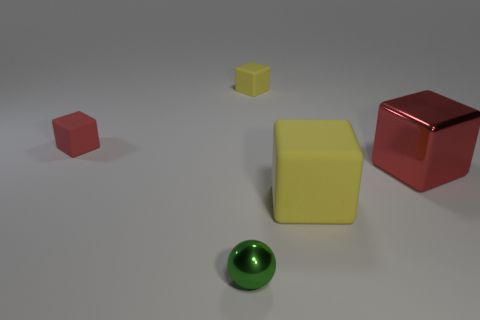There is a yellow thing that is in front of the red cube right of the small red matte object; what size is it?
Provide a succinct answer. Large. Is there another small metal thing that has the same shape as the green metallic object?
Make the answer very short. No. There is a thing that is in front of the big matte object; is its size the same as the block that is behind the small red matte cube?
Provide a succinct answer. Yes. Are there fewer small green spheres left of the small red rubber cube than shiny balls that are to the left of the tiny green ball?
Provide a succinct answer. No. There is another tiny cube that is the same color as the metal cube; what material is it?
Ensure brevity in your answer.  Rubber. There is a tiny cube that is behind the small red cube; what is its color?
Your answer should be very brief. Yellow. Do the big rubber block and the sphere have the same color?
Provide a succinct answer. No. There is a big thing to the left of the red object that is right of the large matte object; how many red rubber cubes are behind it?
Ensure brevity in your answer.  1. How big is the red rubber object?
Provide a short and direct response. Small. What material is the red thing that is the same size as the green ball?
Your answer should be compact. Rubber. 